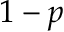Convert formula to latex. <formula><loc_0><loc_0><loc_500><loc_500>1 - p</formula> 